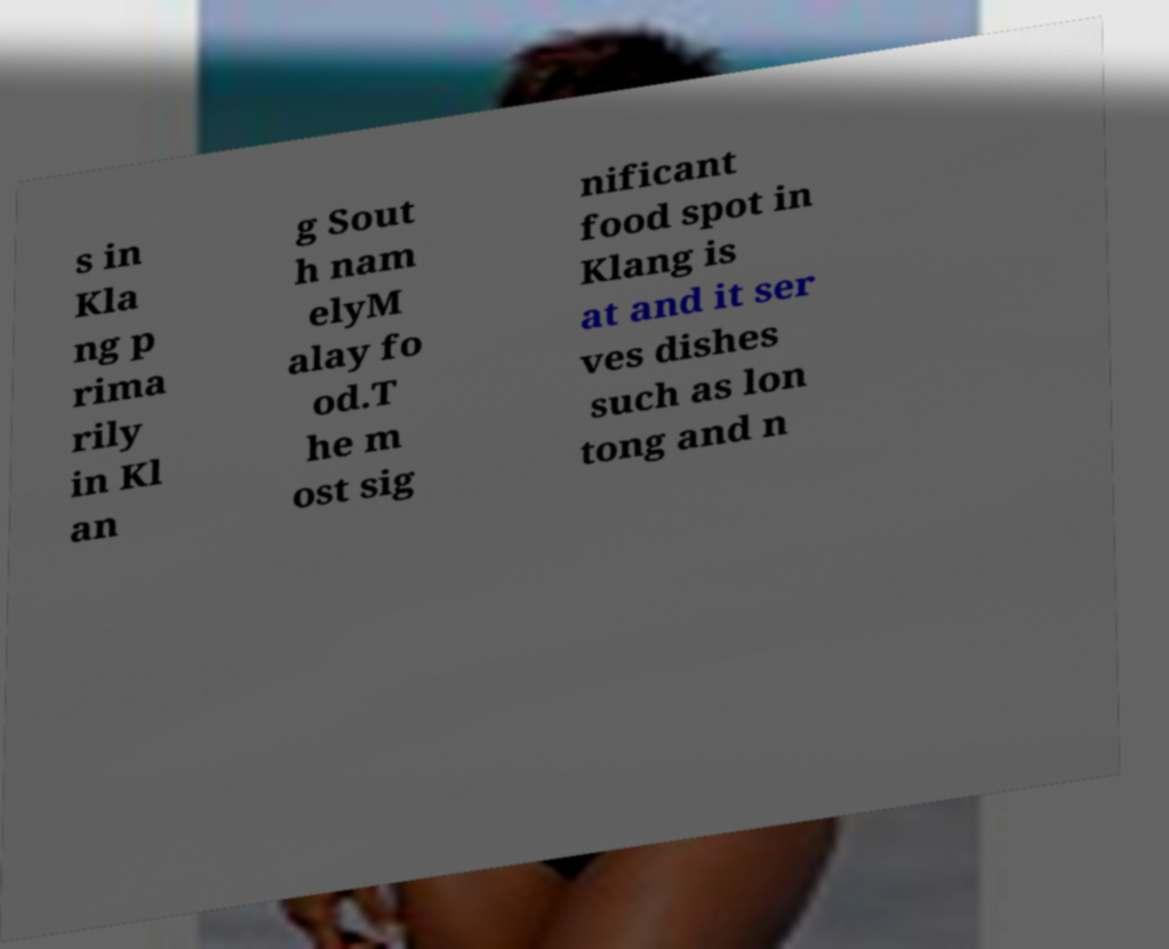Could you extract and type out the text from this image? s in Kla ng p rima rily in Kl an g Sout h nam elyM alay fo od.T he m ost sig nificant food spot in Klang is at and it ser ves dishes such as lon tong and n 